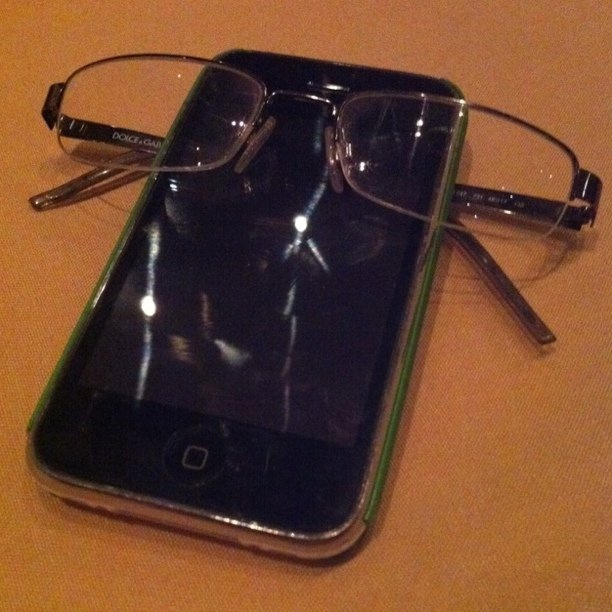Describe the objects in this image and their specific colors. I can see a cell phone in red, black, maroon, and gray tones in this image. 